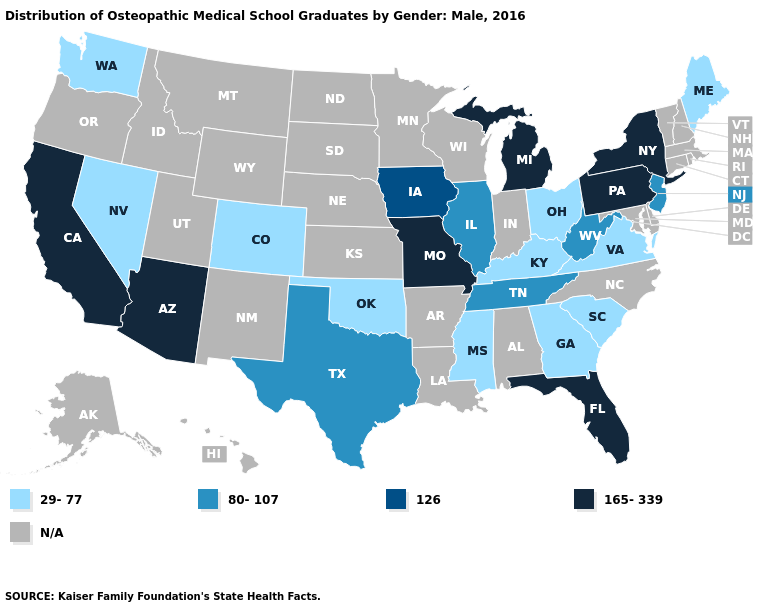Name the states that have a value in the range 126?
Concise answer only. Iowa. Name the states that have a value in the range N/A?
Answer briefly. Alabama, Alaska, Arkansas, Connecticut, Delaware, Hawaii, Idaho, Indiana, Kansas, Louisiana, Maryland, Massachusetts, Minnesota, Montana, Nebraska, New Hampshire, New Mexico, North Carolina, North Dakota, Oregon, Rhode Island, South Dakota, Utah, Vermont, Wisconsin, Wyoming. Does the first symbol in the legend represent the smallest category?
Give a very brief answer. Yes. What is the value of Nevada?
Answer briefly. 29-77. Does the first symbol in the legend represent the smallest category?
Answer briefly. Yes. What is the value of Pennsylvania?
Concise answer only. 165-339. Does Texas have the lowest value in the USA?
Short answer required. No. What is the value of Alabama?
Be succinct. N/A. What is the value of Minnesota?
Be succinct. N/A. What is the highest value in the Northeast ?
Write a very short answer. 165-339. Name the states that have a value in the range N/A?
Answer briefly. Alabama, Alaska, Arkansas, Connecticut, Delaware, Hawaii, Idaho, Indiana, Kansas, Louisiana, Maryland, Massachusetts, Minnesota, Montana, Nebraska, New Hampshire, New Mexico, North Carolina, North Dakota, Oregon, Rhode Island, South Dakota, Utah, Vermont, Wisconsin, Wyoming. Is the legend a continuous bar?
Be succinct. No. What is the value of Texas?
Keep it brief. 80-107. 